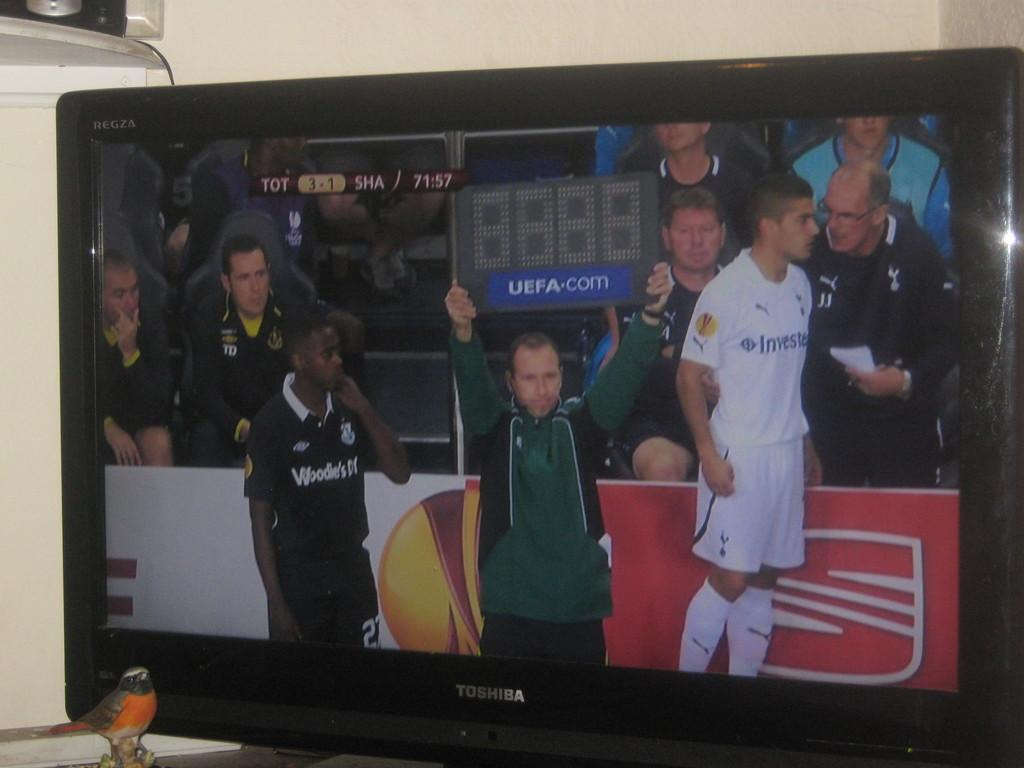<image>
Relay a brief, clear account of the picture shown. A man is holding a board that says UEFA.com over his head as he stands between two athletes. 